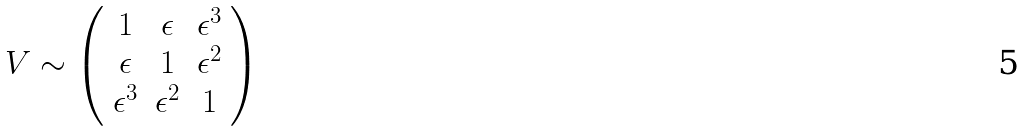<formula> <loc_0><loc_0><loc_500><loc_500>V \sim \left ( \begin{array} { c c c } 1 & \epsilon & \epsilon ^ { 3 } \\ \epsilon & 1 & \epsilon ^ { 2 } \\ \epsilon ^ { 3 } & \epsilon ^ { 2 } & 1 \end{array} \right )</formula> 